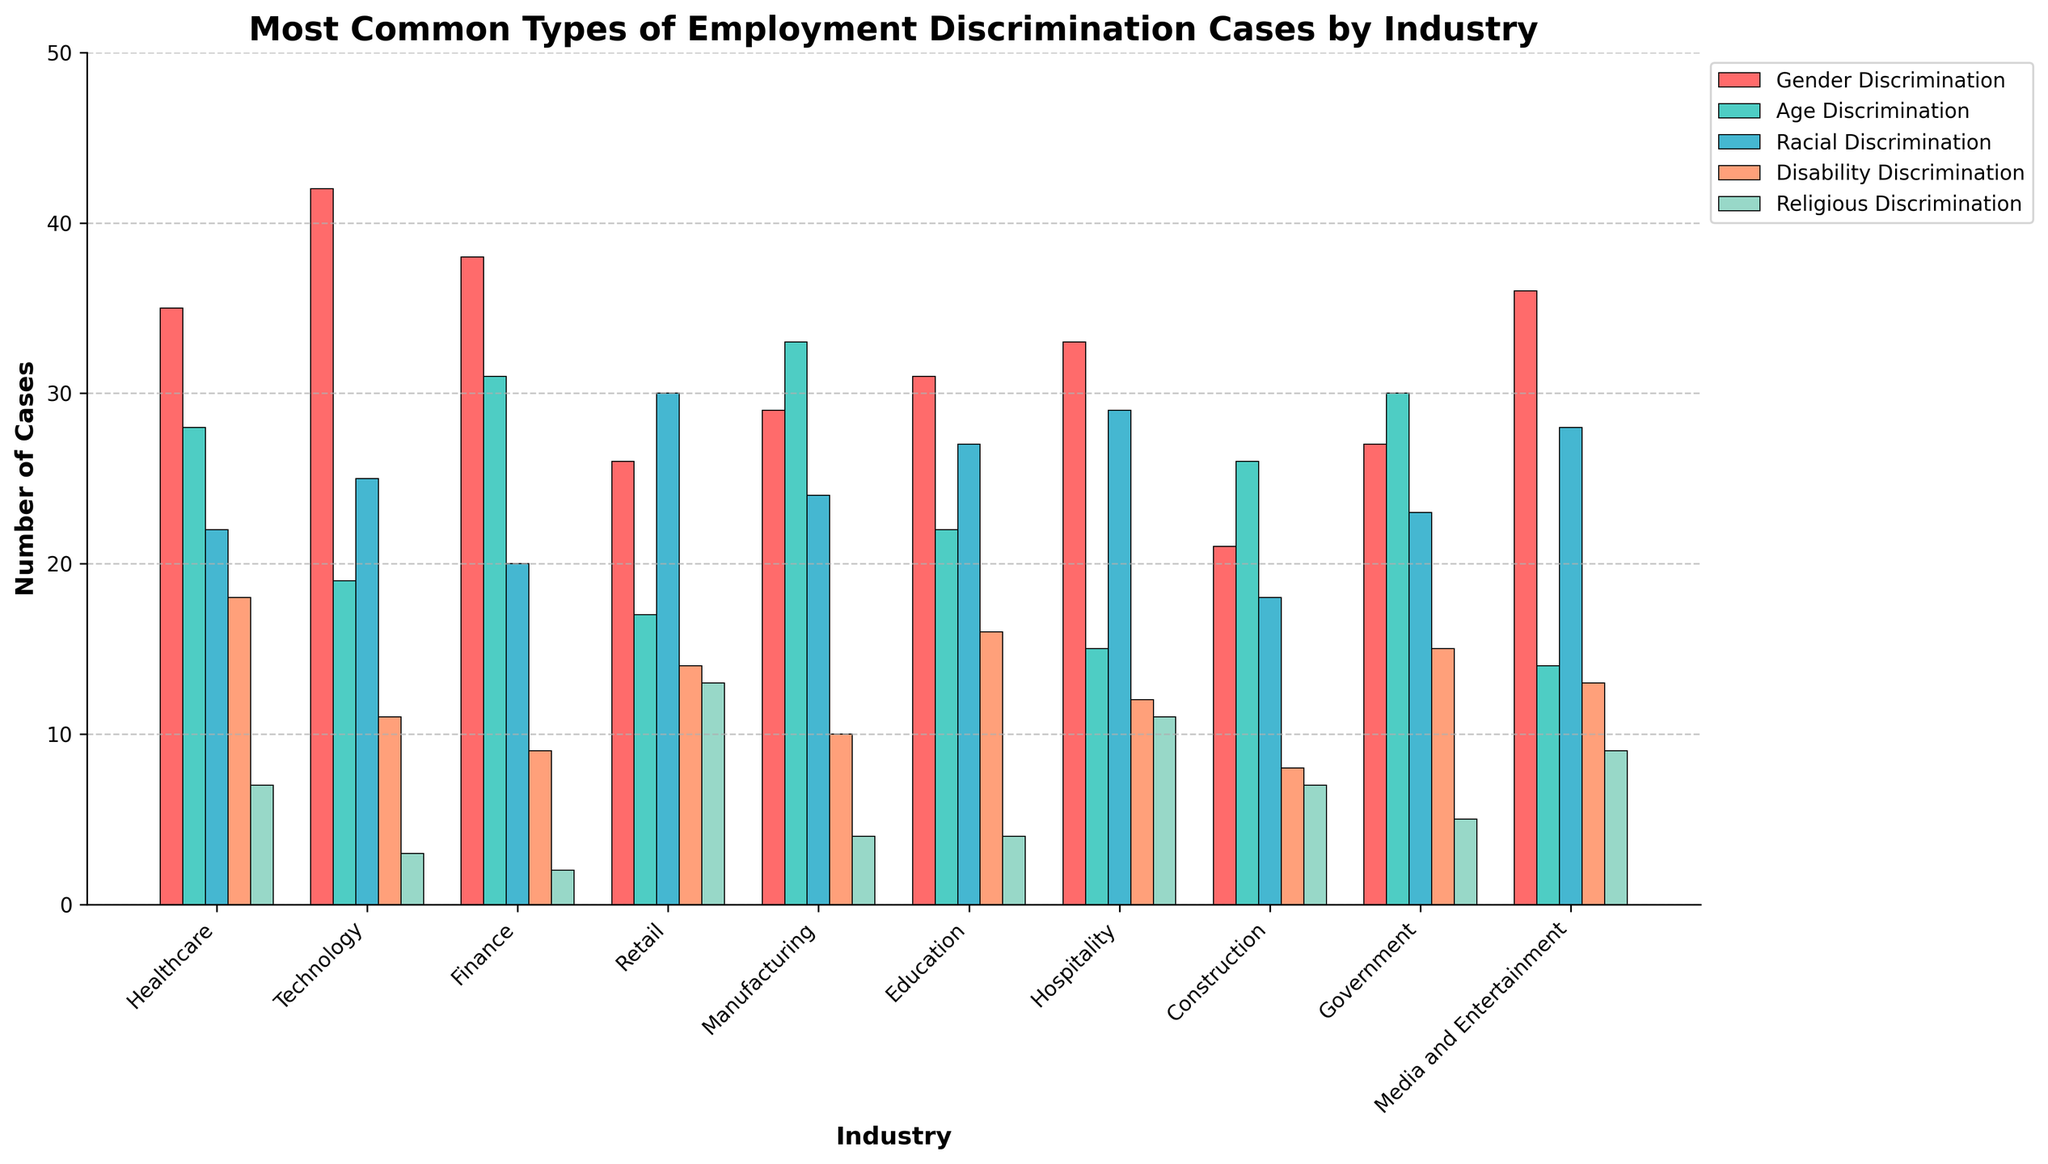Which industry has the highest number of gender discrimination cases? Look for the tallest bar among all the industries corresponding to gender discrimination. The bar for Technology is the highest at 42.
Answer: Technology Which industry has the lowest number of racial discrimination cases? Compare the heights of the bars for racial discrimination across all industries. The bar for Government and Finance are the smallest at 20 each.
Answer: Finance and Government Which type of discrimination is most common in the Hospitality industry? Check which bar is the tallest within the Hospitality cluster. The bar for gender discrimination is the tallest at 33.
Answer: Gender Discrimination How many more age discrimination cases are there in Manufacturing compared to Technology? Find the height of the age discrimination bars for Manufacturing (33) and Technology (19), then calculate the difference as 33 - 19.
Answer: 14 Which industry has the most balanced distribution of different types of discrimination cases? Look for industries where the bars have relatively similar heights across all discrimination types. Education and Government have fairly balanced distributions.
Answer: Education and Government Which discrimination type is the least common overall? Examine all the bars and identify the shortest bars overall. Religious Discrimination bars are the shortest in most industries, particularly in Technology, Finance, and Education.
Answer: Religious Discrimination How many cases of disability discrimination are there in the Retail and Healthcare industries combined? Add the heights of the disability discrimination bars in Retail (14) and Healthcare (18) for a total of 14 + 18.
Answer: 32 In which industry is racial discrimination more prevalent than gender discrimination? Compare the height of racial and gender discrimination bars within each industry. In Retail and Manufacturing, racial discrimination exceeds gender discrimination.
Answer: Retail and Manufacturing What is the average number of gender discrimination cases across all industries? Sum all the gender discrimination cases (35+42+38+26+29+31+33+21+27+36 = 318) and divide by the number of industries (10) to get 318/10.
Answer: 31.8 Which industry has more age discrimination cases than both racial and gender discrimination cases combined? Find industries where the age discrimination bar's height is greater than the sum of the racial and gender discrimination bars. This is the case for none of the provided data.
Answer: None 